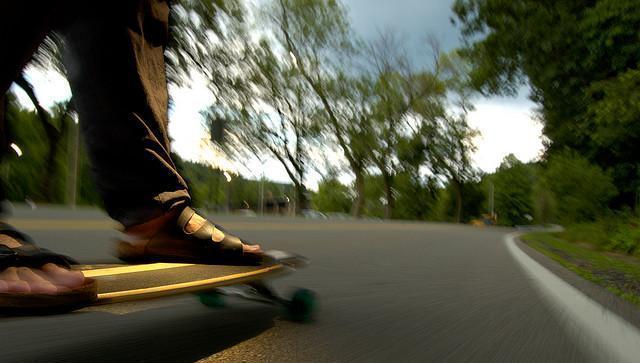How many mugs have a spoon resting inside them?
Give a very brief answer. 0. 